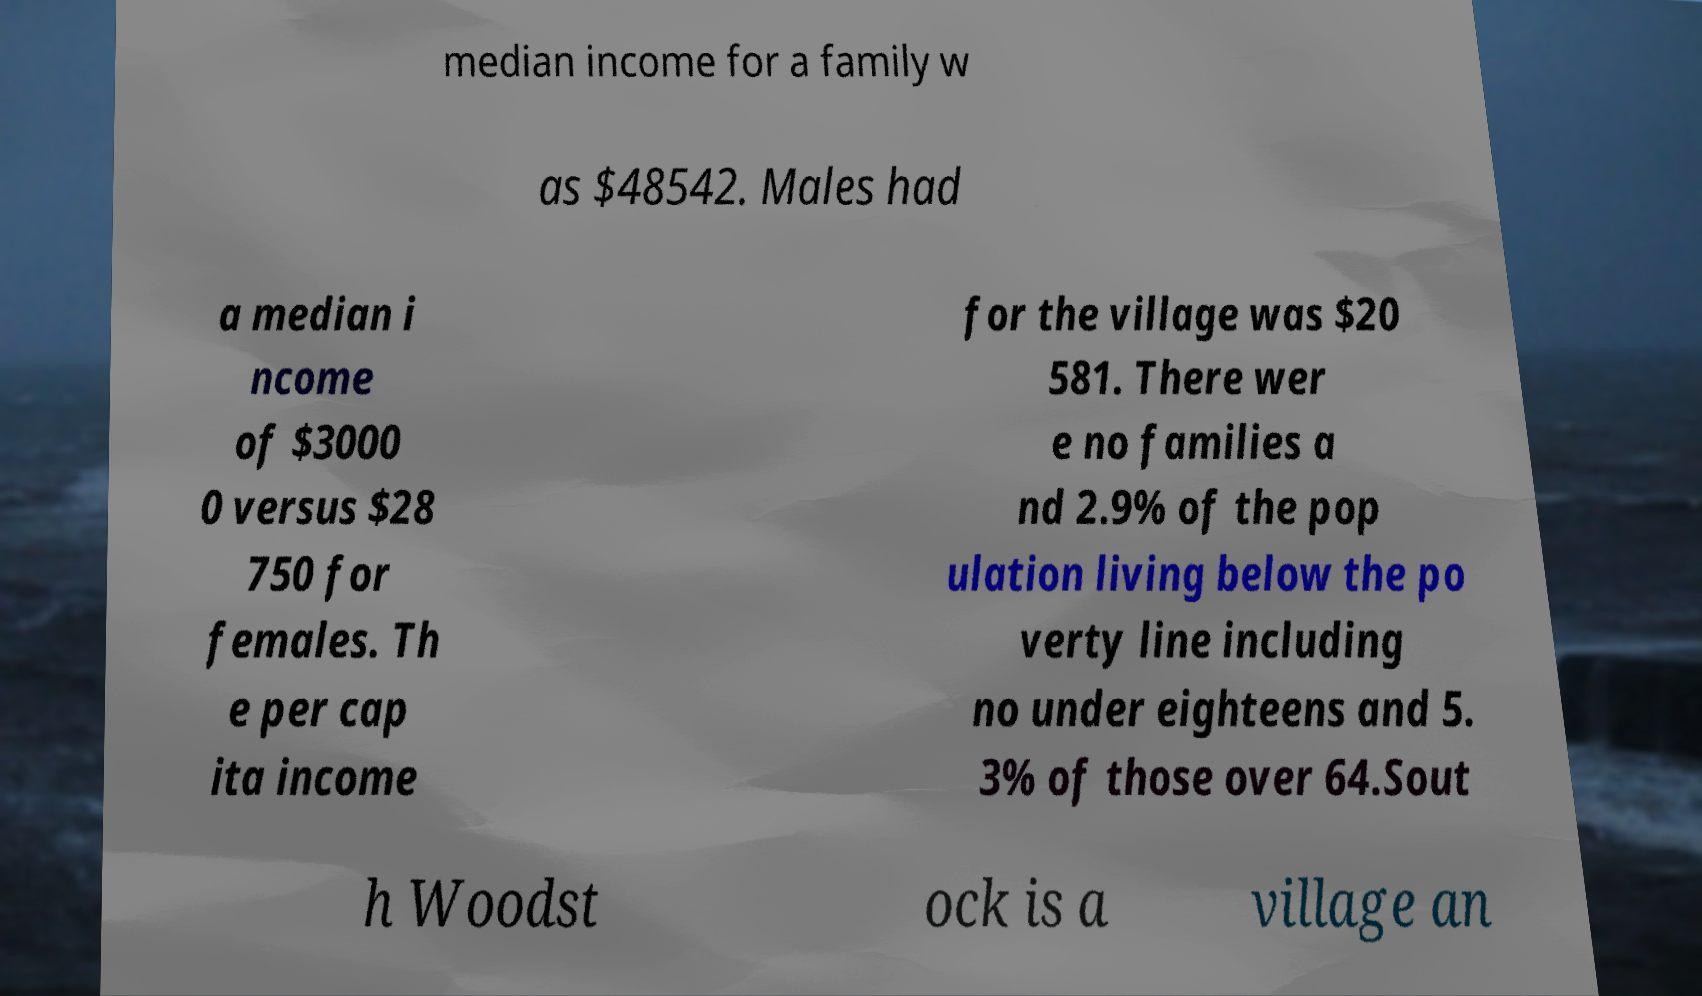Please read and relay the text visible in this image. What does it say? median income for a family w as $48542. Males had a median i ncome of $3000 0 versus $28 750 for females. Th e per cap ita income for the village was $20 581. There wer e no families a nd 2.9% of the pop ulation living below the po verty line including no under eighteens and 5. 3% of those over 64.Sout h Woodst ock is a village an 